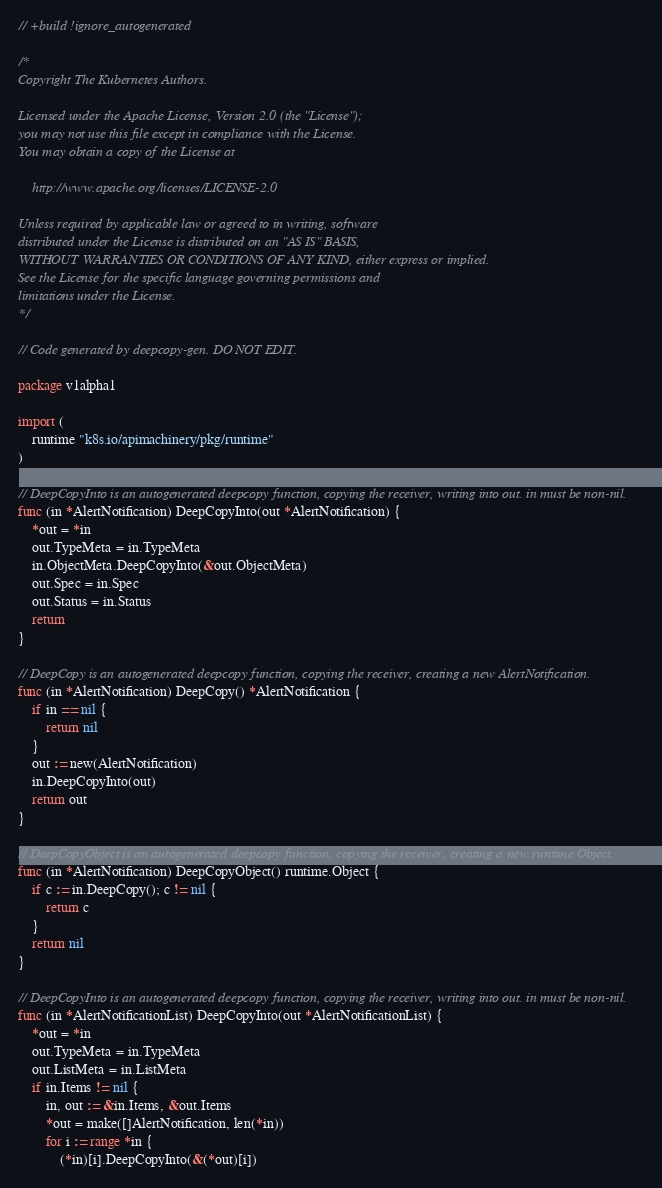Convert code to text. <code><loc_0><loc_0><loc_500><loc_500><_Go_>// +build !ignore_autogenerated

/*
Copyright The Kubernetes Authors.

Licensed under the Apache License, Version 2.0 (the "License");
you may not use this file except in compliance with the License.
You may obtain a copy of the License at

    http://www.apache.org/licenses/LICENSE-2.0

Unless required by applicable law or agreed to in writing, software
distributed under the License is distributed on an "AS IS" BASIS,
WITHOUT WARRANTIES OR CONDITIONS OF ANY KIND, either express or implied.
See the License for the specific language governing permissions and
limitations under the License.
*/

// Code generated by deepcopy-gen. DO NOT EDIT.

package v1alpha1

import (
	runtime "k8s.io/apimachinery/pkg/runtime"
)

// DeepCopyInto is an autogenerated deepcopy function, copying the receiver, writing into out. in must be non-nil.
func (in *AlertNotification) DeepCopyInto(out *AlertNotification) {
	*out = *in
	out.TypeMeta = in.TypeMeta
	in.ObjectMeta.DeepCopyInto(&out.ObjectMeta)
	out.Spec = in.Spec
	out.Status = in.Status
	return
}

// DeepCopy is an autogenerated deepcopy function, copying the receiver, creating a new AlertNotification.
func (in *AlertNotification) DeepCopy() *AlertNotification {
	if in == nil {
		return nil
	}
	out := new(AlertNotification)
	in.DeepCopyInto(out)
	return out
}

// DeepCopyObject is an autogenerated deepcopy function, copying the receiver, creating a new runtime.Object.
func (in *AlertNotification) DeepCopyObject() runtime.Object {
	if c := in.DeepCopy(); c != nil {
		return c
	}
	return nil
}

// DeepCopyInto is an autogenerated deepcopy function, copying the receiver, writing into out. in must be non-nil.
func (in *AlertNotificationList) DeepCopyInto(out *AlertNotificationList) {
	*out = *in
	out.TypeMeta = in.TypeMeta
	out.ListMeta = in.ListMeta
	if in.Items != nil {
		in, out := &in.Items, &out.Items
		*out = make([]AlertNotification, len(*in))
		for i := range *in {
			(*in)[i].DeepCopyInto(&(*out)[i])</code> 